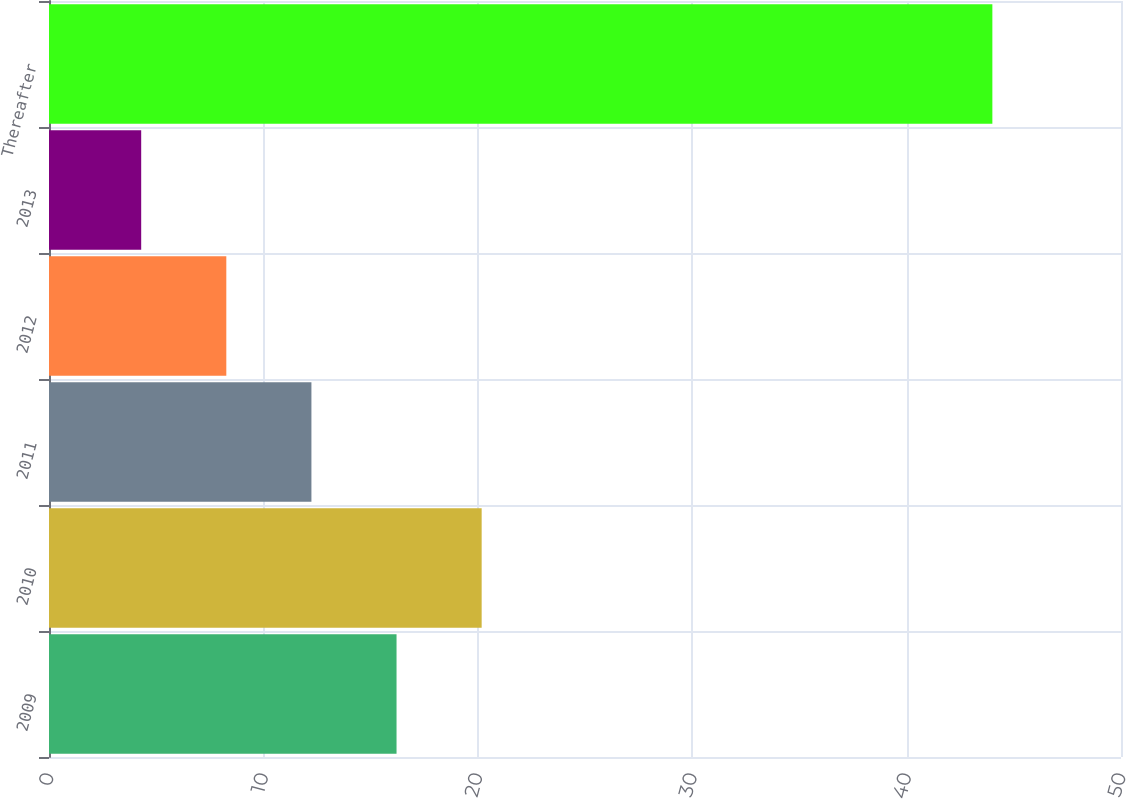<chart> <loc_0><loc_0><loc_500><loc_500><bar_chart><fcel>2009<fcel>2010<fcel>2011<fcel>2012<fcel>2013<fcel>Thereafter<nl><fcel>16.21<fcel>20.18<fcel>12.24<fcel>8.27<fcel>4.3<fcel>44<nl></chart> 